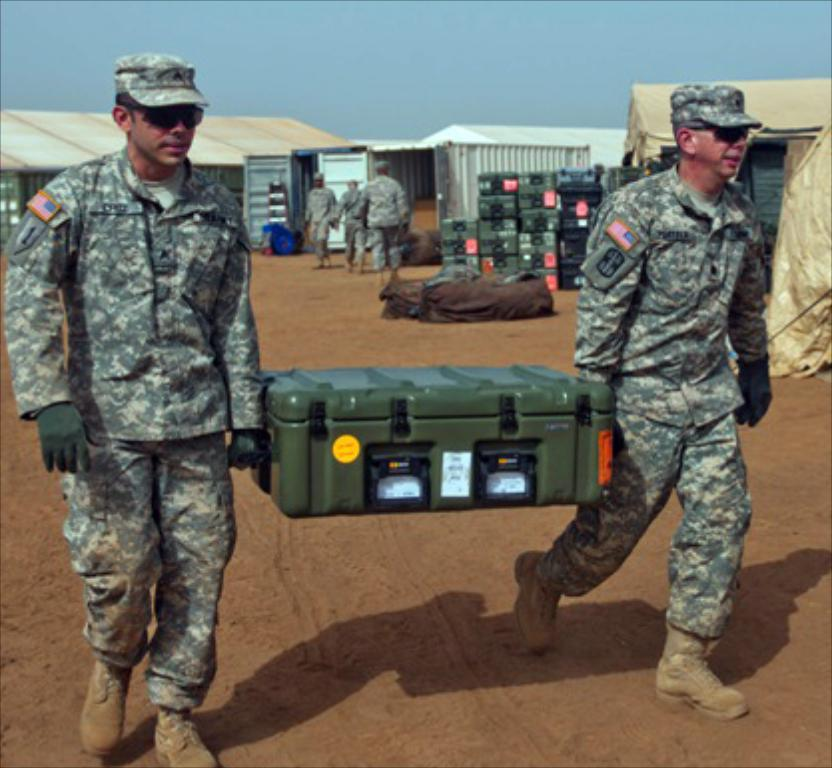How many soldiers are in the image? There are two soldiers in the image. What type of protective gear are the soldiers wearing? The soldiers are wearing caps, goggles, and gloves. What are the soldiers holding in the image? The soldiers are holding a box. What can be seen in the background of the image? There are sheds, boxes, and people in the background of the image. The sky is also visible in the background. What type of song is being sung by the trees in the image? There are no trees present in the image, and therefore no such activity can be observed. 